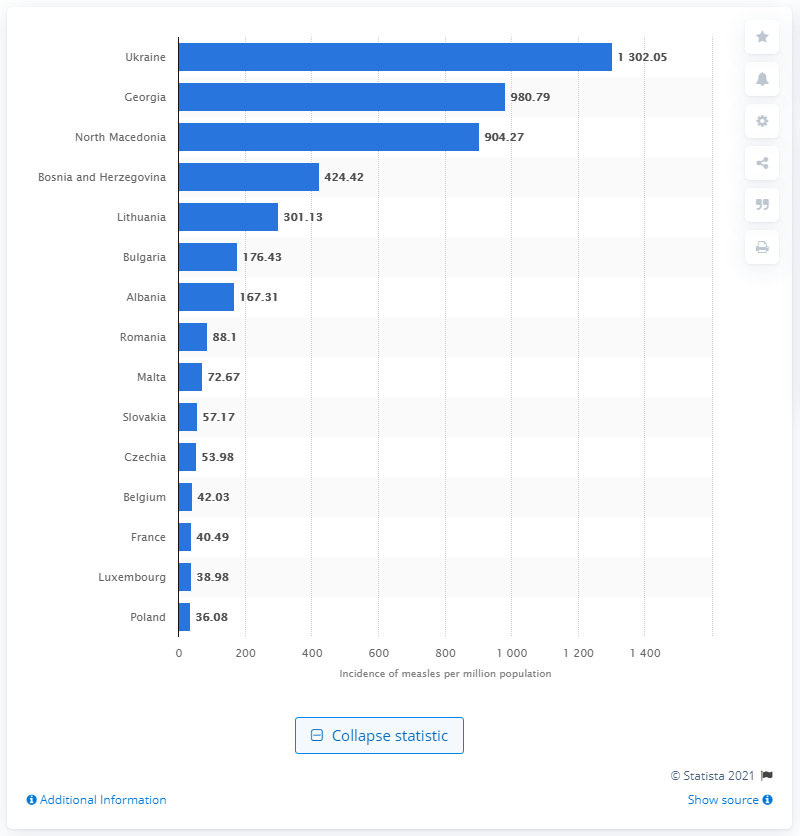Highlight a few significant elements in this photo. In 2019, Ukraine had the highest rate of measles in Europe. 